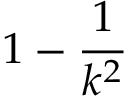<formula> <loc_0><loc_0><loc_500><loc_500>1 - { \frac { 1 } { k ^ { 2 } } }</formula> 